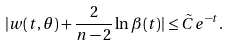<formula> <loc_0><loc_0><loc_500><loc_500>| w ( t , \theta ) + \frac { 2 } { n - 2 } \ln \beta ( t ) | \leq \tilde { C } e ^ { - t } .</formula> 